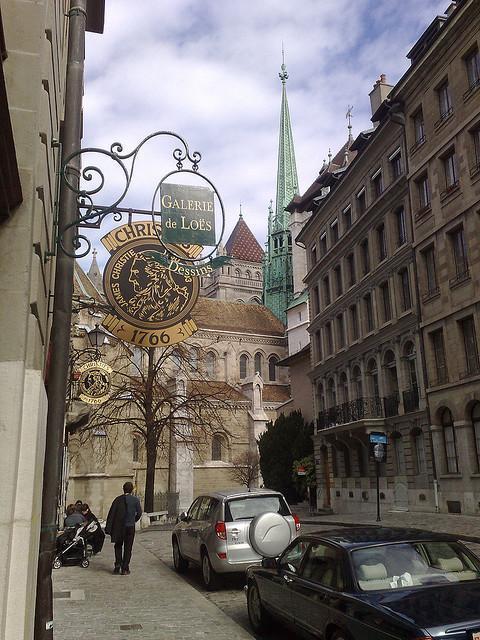How many stories tall is the building on the right?
Give a very brief answer. 5. How many vehicles do you see?
Give a very brief answer. 2. How many vehicles are in the photo?
Give a very brief answer. 2. How many cars are in the scene?
Give a very brief answer. 2. How many items are on the top of the car?
Give a very brief answer. 0. How many people can you see?
Give a very brief answer. 1. How many cars are there?
Give a very brief answer. 2. 